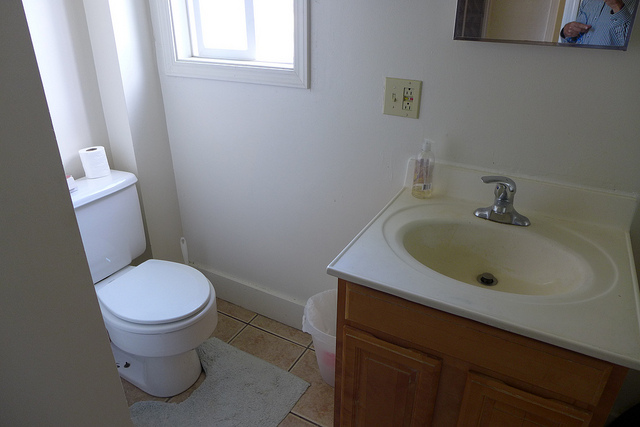What color is the bathroom cabinet? The bathroom cabinet has a light brown or tan color, consistent with a natural wood finish. 